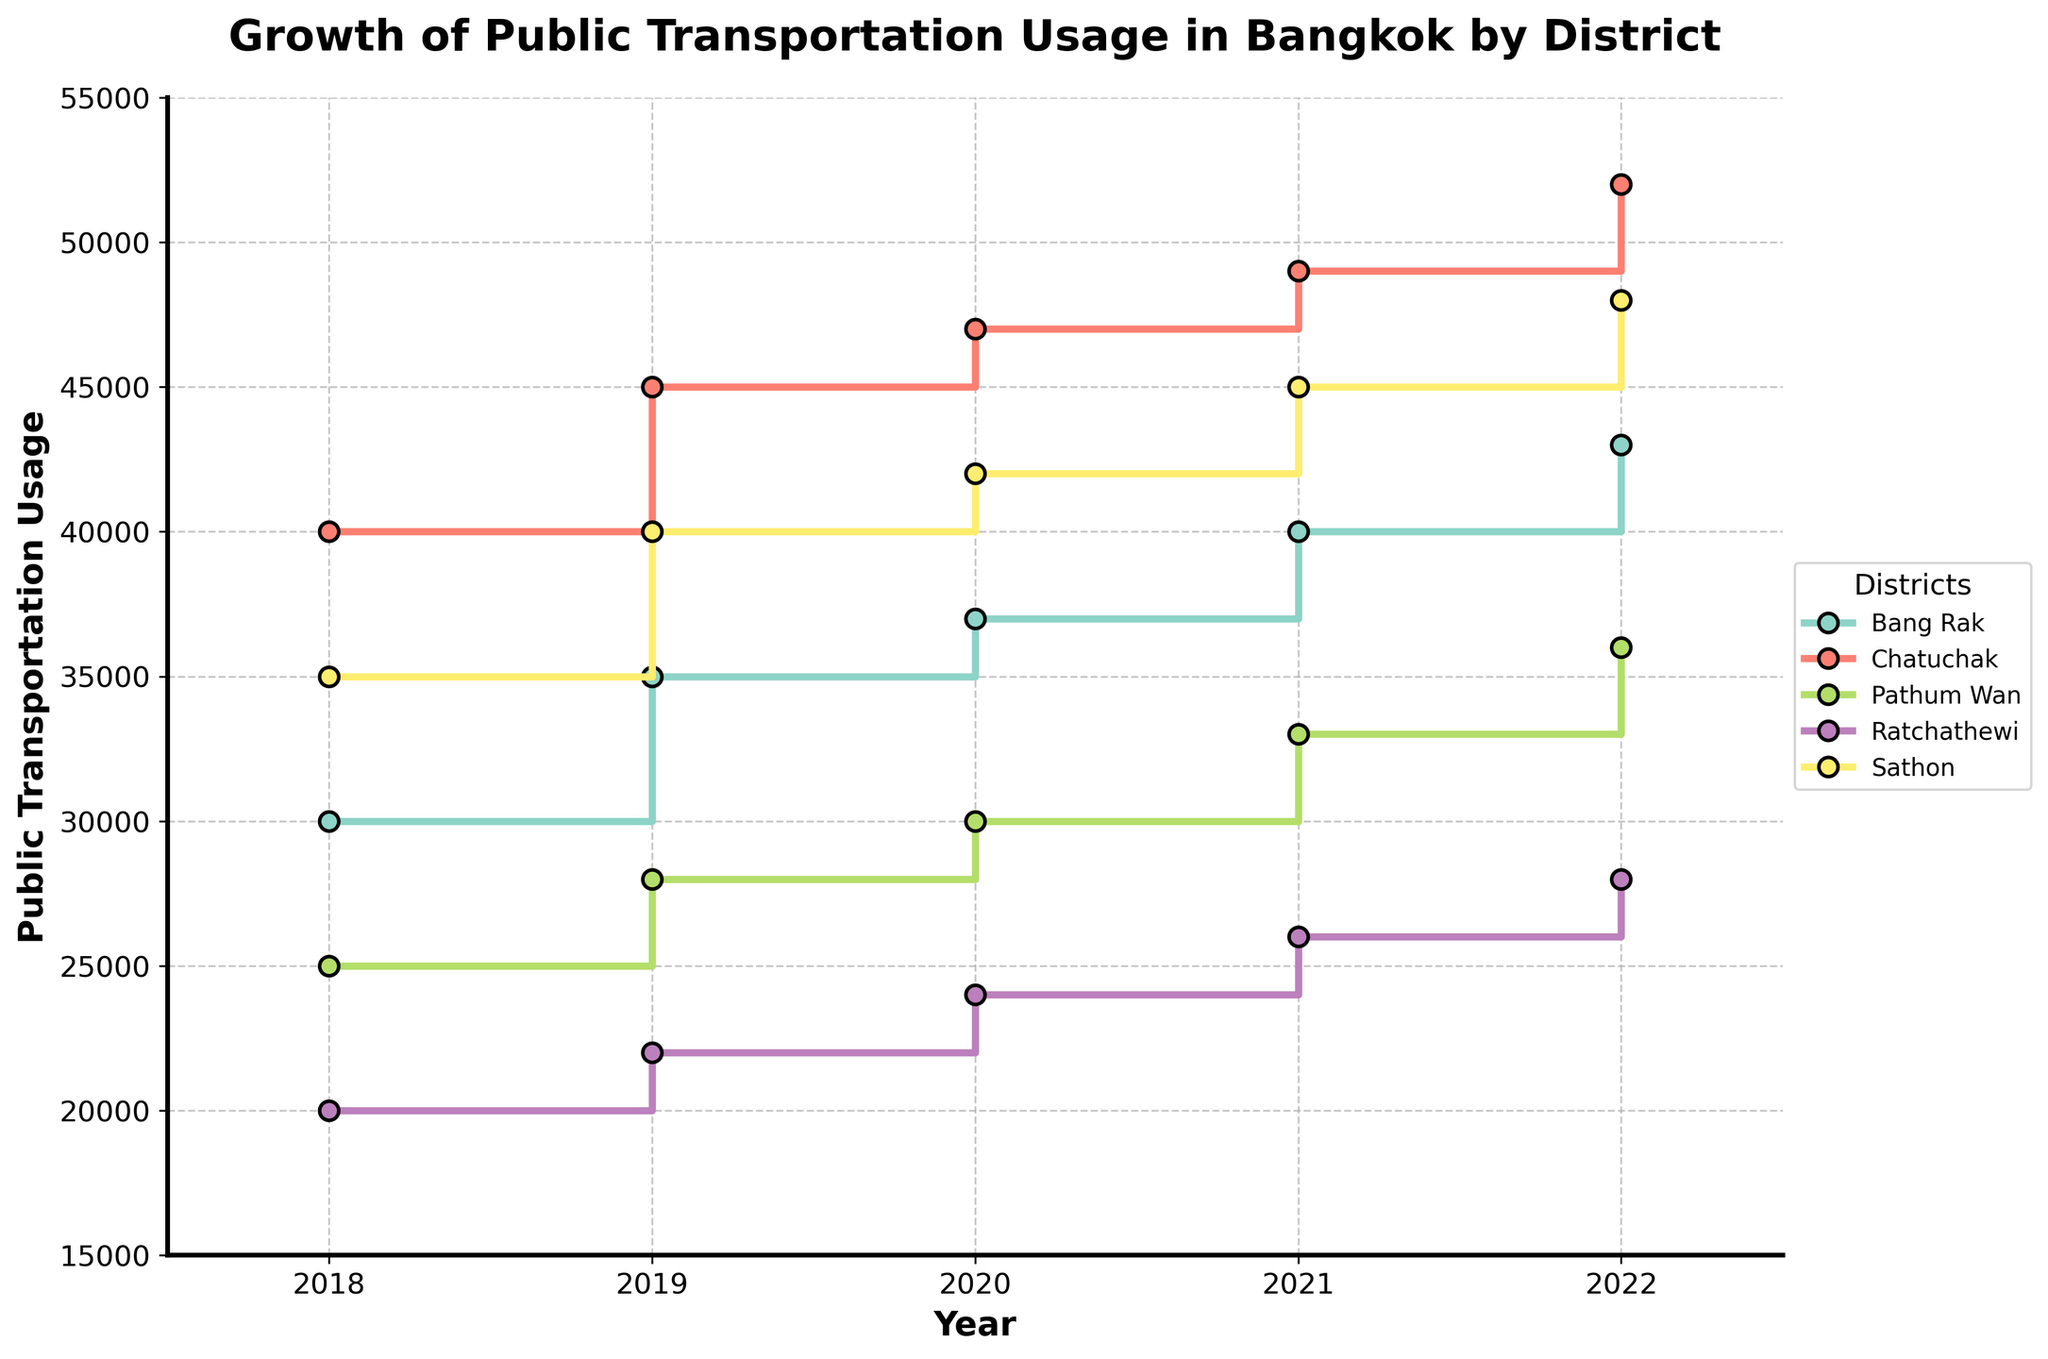How many districts are represented in the figure? The figure plots data for each district. By counting the unique legends in the figure, we can see there are five districts: Bang Rak, Chatuchak, Pathum Wan, Ratchathewi, and Sathon.
Answer: 5 Which district had the highest public transportation usage in 2022? Reviewing the endpoint of each district's line representing the year 2022, the district with the highest value is Chatuchak.
Answer: Chatuchak What was the total usage of public transportation in all districts in 2021? For each district, sum the public transportation numbers for the year 2021: (40000 + 49000 + 33000 + 26000 + 45000) = 193000.
Answer: 193000 Which district showed the highest increase in public transportation usage from 2018 to 2019? Calculate the difference for each district: 
Bang Rak: 35000 - 30000 = 5000, 
Chatuchak: 45000 - 40000 = 5000, 
Pathum Wan: 28000 - 25000 = 3000, 
Ratchathewi: 22000 - 20000 = 2000, 
Sathon: 40000 - 35000 = 5000.
The highest increase is shared by Bang Rak, Chatuchak, and Sathon with an increase of 5000 each.
Answer: Bang Rak, Chatuchak, Sathon Which district had the least public transportation usage in 2020? Compare the values for each district in 2020. Ratchathewi had the least usage with 24000.
Answer: Ratchathewi What is the average public transportation usage for Pathum Wan over the years shown? Add the values for Pathum Wan and divide by the number of years: (25000 + 28000 + 30000 + 33000 + 36000) / 5 = 30400.
Answer: 30400 By how much did the public transportation usage in Sathon increase from 2018 to 2022? Calculate the difference for Sathon: 48000 - 35000 = 13000.
Answer: 13000 Which year shows the largest collective increase in public transportation usage for all districts combined? Compare yearly changes in usage:
2018 to 2019: (35000-30000) + (45000-40000) + (28000-25000) + (22000-20000) + (40000-35000) = 18000,
2019 to 2020: (37000-35000) + (47000-45000) + (30000-28000) + (24000-22000) + (42000-40000) = 13000,
2020 to 2021: (40000-37000) + (49000-47000) + (33000-30000) + (26000-24000) + (45000-42000) = 14000,
2021 to 2022: (43000-40000) + (52000-49000) + (36000-33000) + (28000-26000) + (48000-45000) = 15000.
The largest increase is from 2018 to 2019, which is 18000.
Answer: 2018 to 2019 How does the trend in public transportation usage in Ratchathewi compare to Chatuchak over the years? Both districts show a steady increase each year. However, Chatuchak consistently has higher usage and larger increases compared to Ratchathewi.
Answer: Chatuchak has higher usage and increases What is the difference in public transportation usage between Bang Rak and Pathum Wan in 2022? Subtract the 2022 values: 43000 (Bang Rak) - 36000 (Pathum Wan) = 7000.
Answer: 7000 